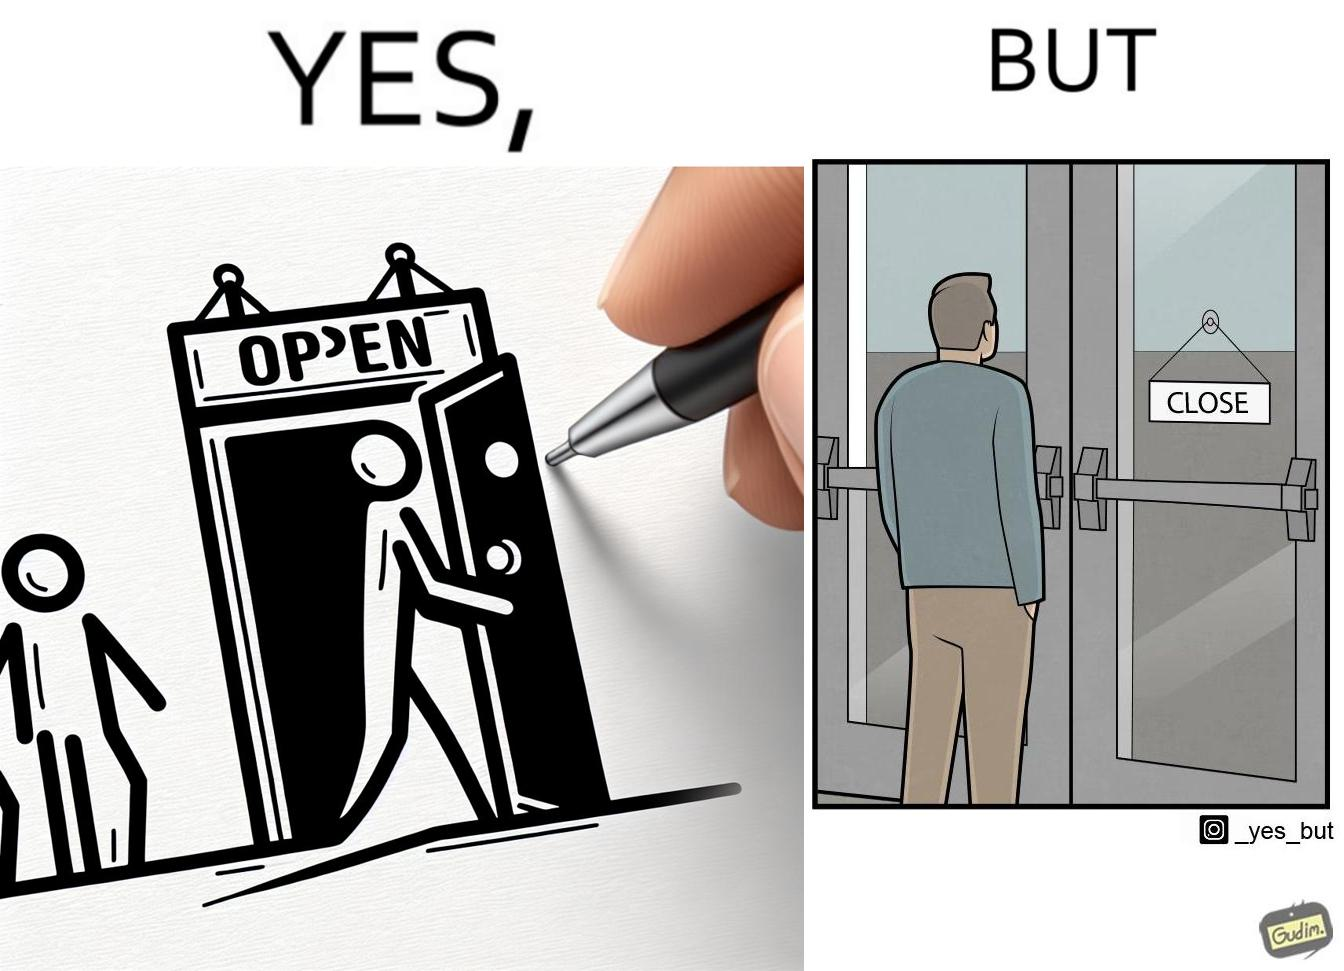What is shown in this image? The image is funny because a person opens a door with the sign 'OPEN', meaning the place is open. However, once the person enters the building and looks back, the other side of the sign reads 'CLOSE', which ideally should not be the case, as the place is actually open. 